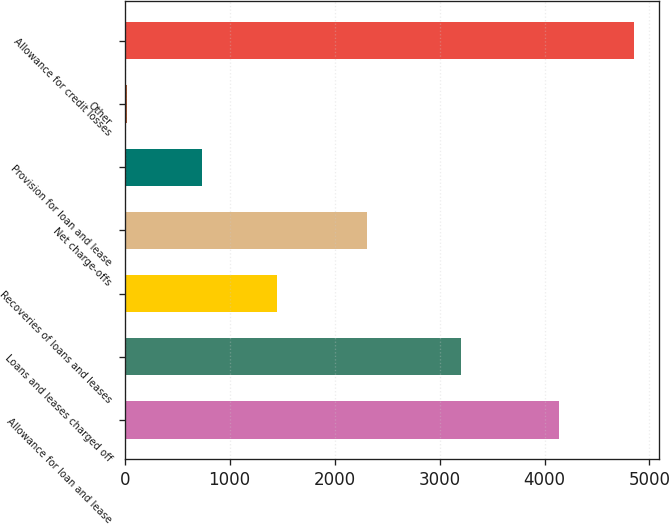<chart> <loc_0><loc_0><loc_500><loc_500><bar_chart><fcel>Allowance for loan and lease<fcel>Loans and leases charged off<fcel>Recoveries of loans and leases<fcel>Net charge-offs<fcel>Provision for loan and lease<fcel>Other<fcel>Allowance for credit losses<nl><fcel>4135<fcel>3204<fcel>1454.8<fcel>2313<fcel>740.4<fcel>26<fcel>4849.4<nl></chart> 